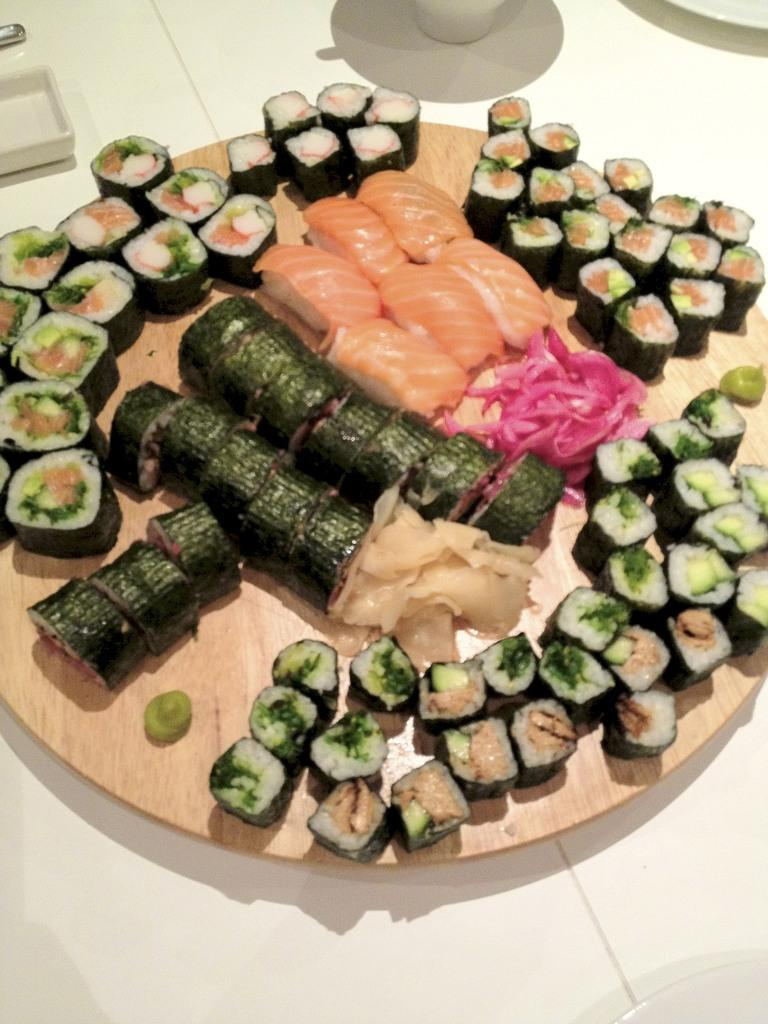What type of food can be seen in the image? There is food in the image, including meat. How is the food arranged or presented in the image? The food and meat are on a wooden tray. What can be seen in the background of the image? There is a table visible in the background of the image. How many boats are visible in the image? There are no boats present in the image. Is there a woman preparing the food in the image? The image does not show any people, so it cannot be determined if a woman is present or preparing the food. 